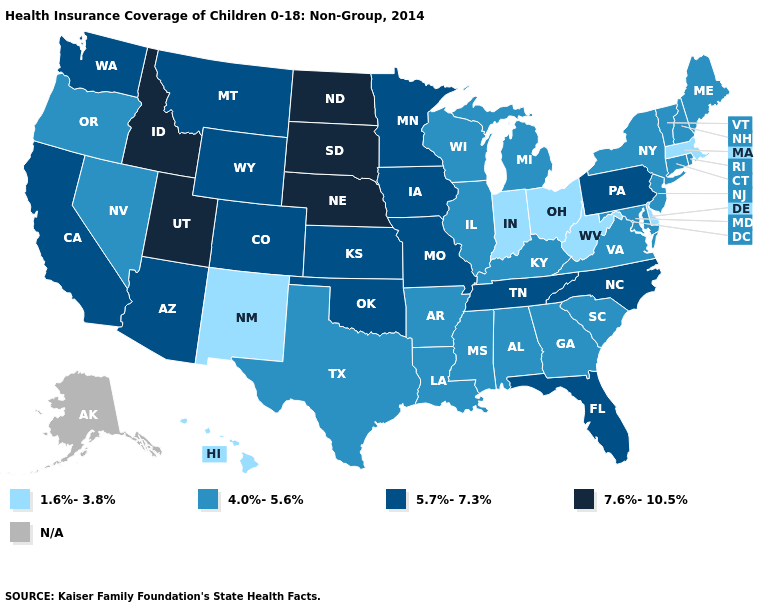What is the value of South Carolina?
Be succinct. 4.0%-5.6%. What is the value of South Dakota?
Concise answer only. 7.6%-10.5%. What is the lowest value in the USA?
Keep it brief. 1.6%-3.8%. Among the states that border Kansas , which have the highest value?
Keep it brief. Nebraska. What is the value of Nevada?
Answer briefly. 4.0%-5.6%. What is the value of New Jersey?
Quick response, please. 4.0%-5.6%. What is the value of Ohio?
Write a very short answer. 1.6%-3.8%. Does Indiana have the lowest value in the USA?
Keep it brief. Yes. Does Idaho have the highest value in the West?
Be succinct. Yes. Name the states that have a value in the range N/A?
Be succinct. Alaska. Is the legend a continuous bar?
Keep it brief. No. Name the states that have a value in the range 1.6%-3.8%?
Quick response, please. Delaware, Hawaii, Indiana, Massachusetts, New Mexico, Ohio, West Virginia. Among the states that border Massachusetts , which have the lowest value?
Keep it brief. Connecticut, New Hampshire, New York, Rhode Island, Vermont. Among the states that border Wisconsin , does Iowa have the highest value?
Keep it brief. Yes. Name the states that have a value in the range 5.7%-7.3%?
Quick response, please. Arizona, California, Colorado, Florida, Iowa, Kansas, Minnesota, Missouri, Montana, North Carolina, Oklahoma, Pennsylvania, Tennessee, Washington, Wyoming. 